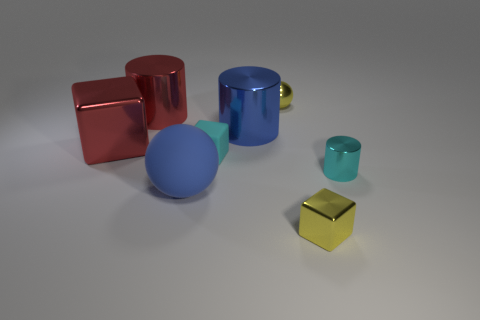Add 1 large cyan blocks. How many objects exist? 9 Subtract all small cubes. How many cubes are left? 1 Subtract all spheres. How many objects are left? 6 Add 2 tiny cyan blocks. How many tiny cyan blocks exist? 3 Subtract 1 blue balls. How many objects are left? 7 Subtract all gray cylinders. Subtract all purple blocks. How many cylinders are left? 3 Subtract all purple spheres. Subtract all red metal objects. How many objects are left? 6 Add 2 cyan blocks. How many cyan blocks are left? 3 